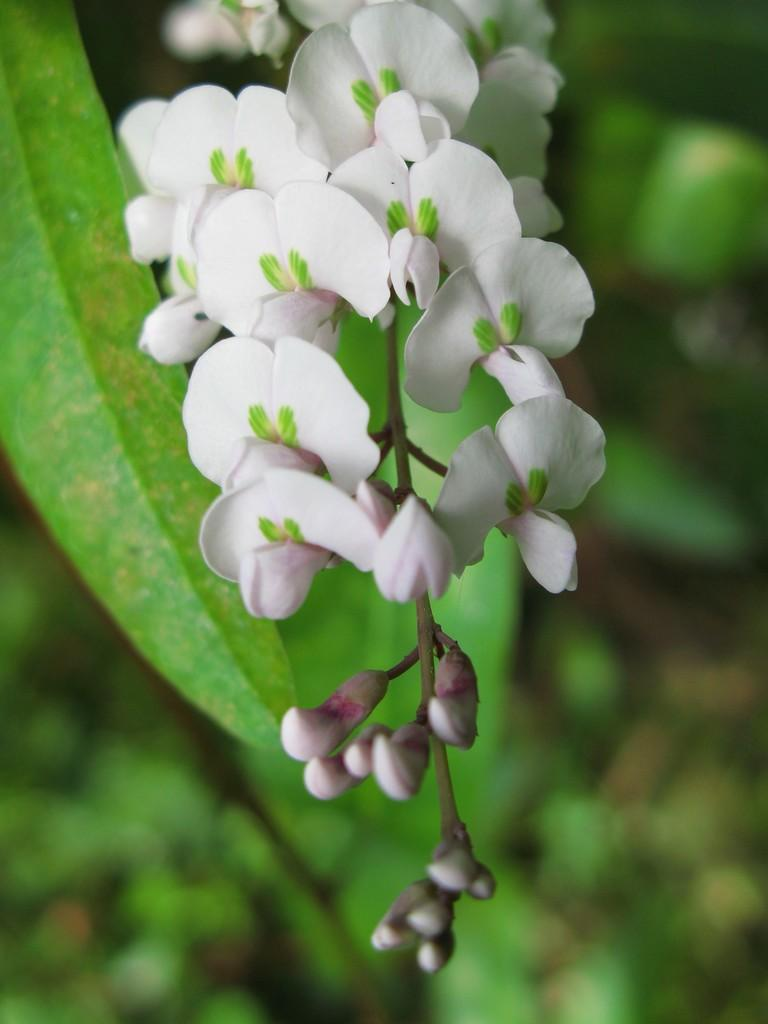What type of plant life is present in the image? There are flowers, buds on a stem, and leaves in the image. Can you describe the stage of growth for the flowers in the image? The image shows buds on a stem, indicating that the flowers are in the process of blooming. What can be observed about the background of the image? The background of the image is blurry. What type of cheese can be seen on the twig in the image? There is no cheese or twig present in the image; it features flowers, buds on a stem, and leaves. 